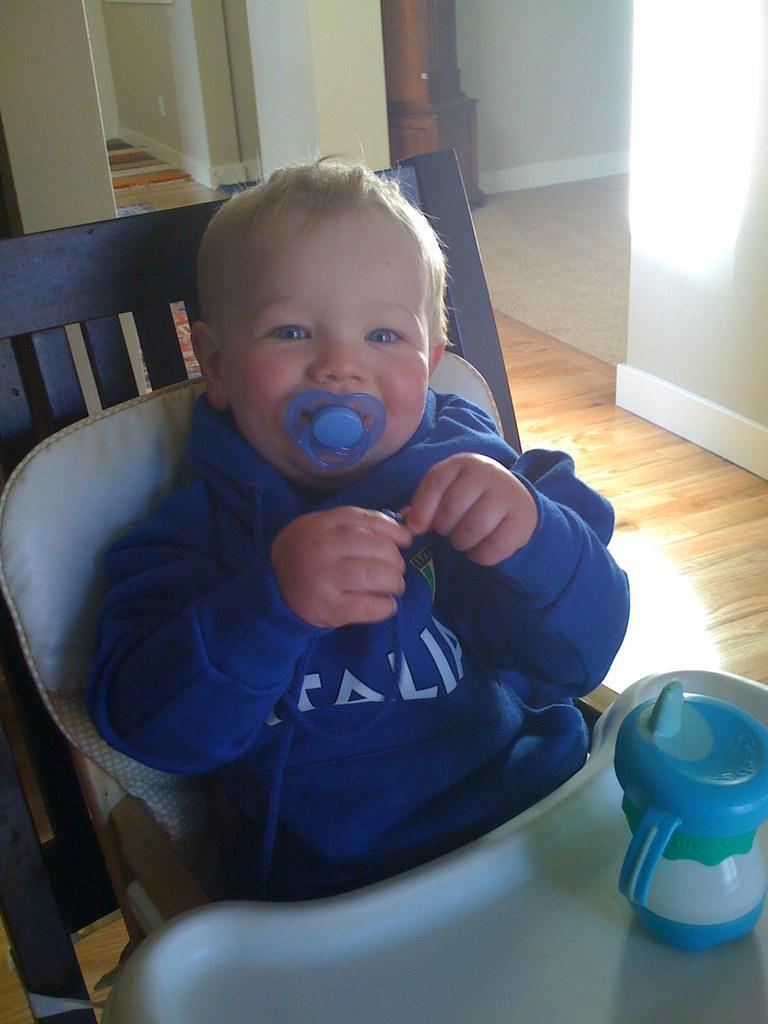Describe this image in one or two sentences. In this picture there is a small boy in the center of the image on a chair and there is a baby water bottle in front of him, it seems to be there is a door and a pillar in the background area of the image. 